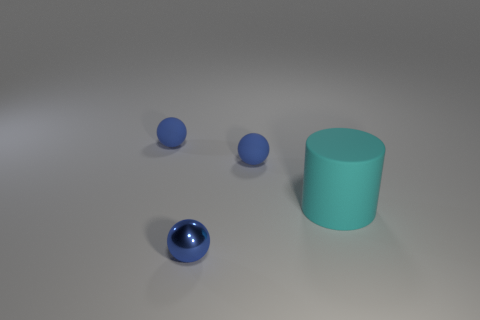Can you describe the lighting and shadows visible in the image? Certainly. In the image, the lighting seems to be coming from the top left, casting soft shadows to the right of the objects. It gives the scene a calm and evenly lit ambiance, highlighting the texture differences between the metallic, matte, and presumably rubber surfaces of the spheres and cylinder. 